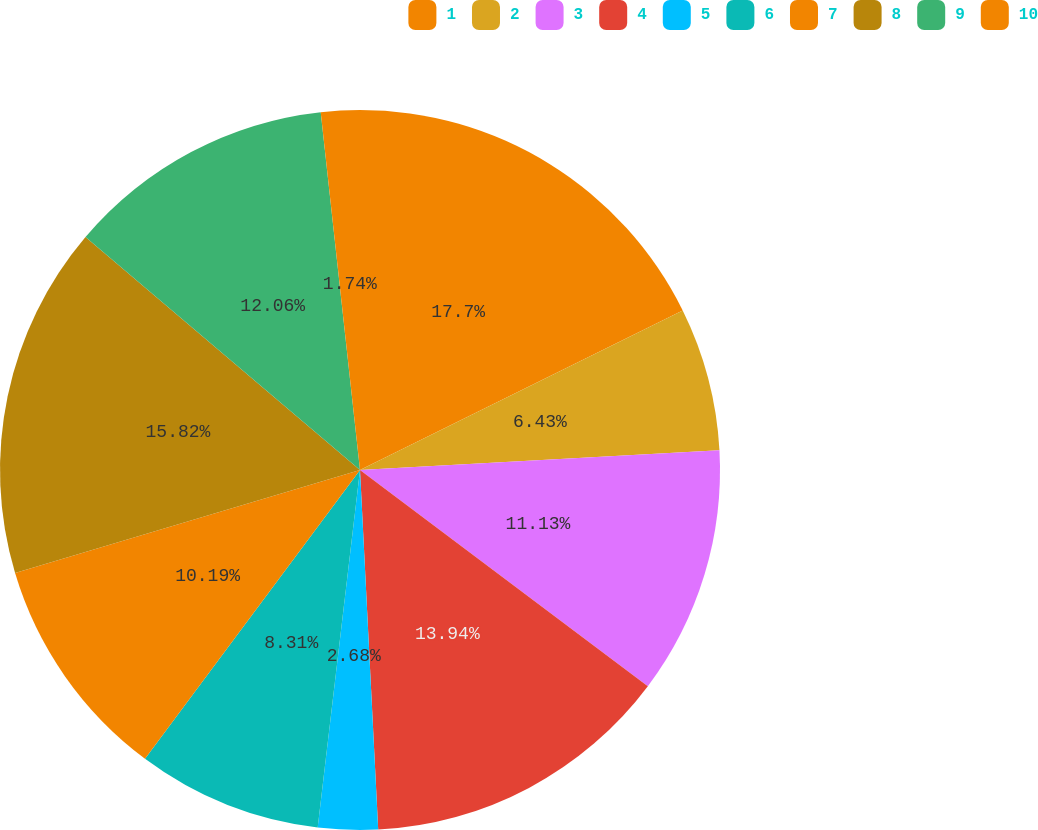<chart> <loc_0><loc_0><loc_500><loc_500><pie_chart><fcel>1<fcel>2<fcel>3<fcel>4<fcel>5<fcel>6<fcel>7<fcel>8<fcel>9<fcel>10<nl><fcel>17.69%<fcel>6.43%<fcel>11.13%<fcel>13.94%<fcel>2.68%<fcel>8.31%<fcel>10.19%<fcel>15.82%<fcel>12.06%<fcel>1.74%<nl></chart> 